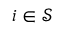Convert formula to latex. <formula><loc_0><loc_0><loc_500><loc_500>i \in \mathcal { S }</formula> 